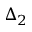Convert formula to latex. <formula><loc_0><loc_0><loc_500><loc_500>\Delta _ { 2 }</formula> 